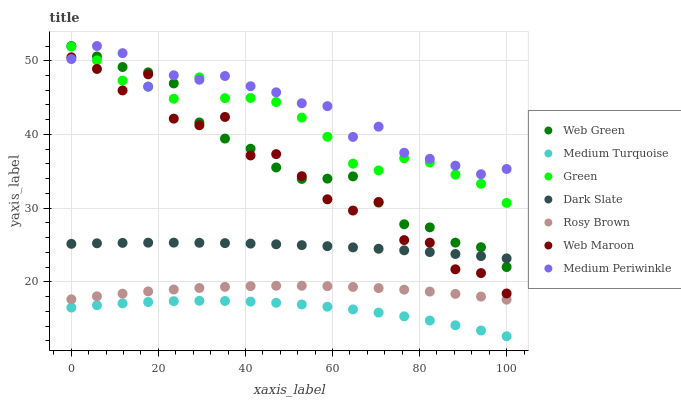Does Medium Turquoise have the minimum area under the curve?
Answer yes or no. Yes. Does Medium Periwinkle have the maximum area under the curve?
Answer yes or no. Yes. Does Rosy Brown have the minimum area under the curve?
Answer yes or no. No. Does Rosy Brown have the maximum area under the curve?
Answer yes or no. No. Is Dark Slate the smoothest?
Answer yes or no. Yes. Is Web Maroon the roughest?
Answer yes or no. Yes. Is Rosy Brown the smoothest?
Answer yes or no. No. Is Rosy Brown the roughest?
Answer yes or no. No. Does Medium Turquoise have the lowest value?
Answer yes or no. Yes. Does Rosy Brown have the lowest value?
Answer yes or no. No. Does Web Green have the highest value?
Answer yes or no. Yes. Does Rosy Brown have the highest value?
Answer yes or no. No. Is Medium Turquoise less than Dark Slate?
Answer yes or no. Yes. Is Web Green greater than Medium Turquoise?
Answer yes or no. Yes. Does Dark Slate intersect Web Green?
Answer yes or no. Yes. Is Dark Slate less than Web Green?
Answer yes or no. No. Is Dark Slate greater than Web Green?
Answer yes or no. No. Does Medium Turquoise intersect Dark Slate?
Answer yes or no. No. 